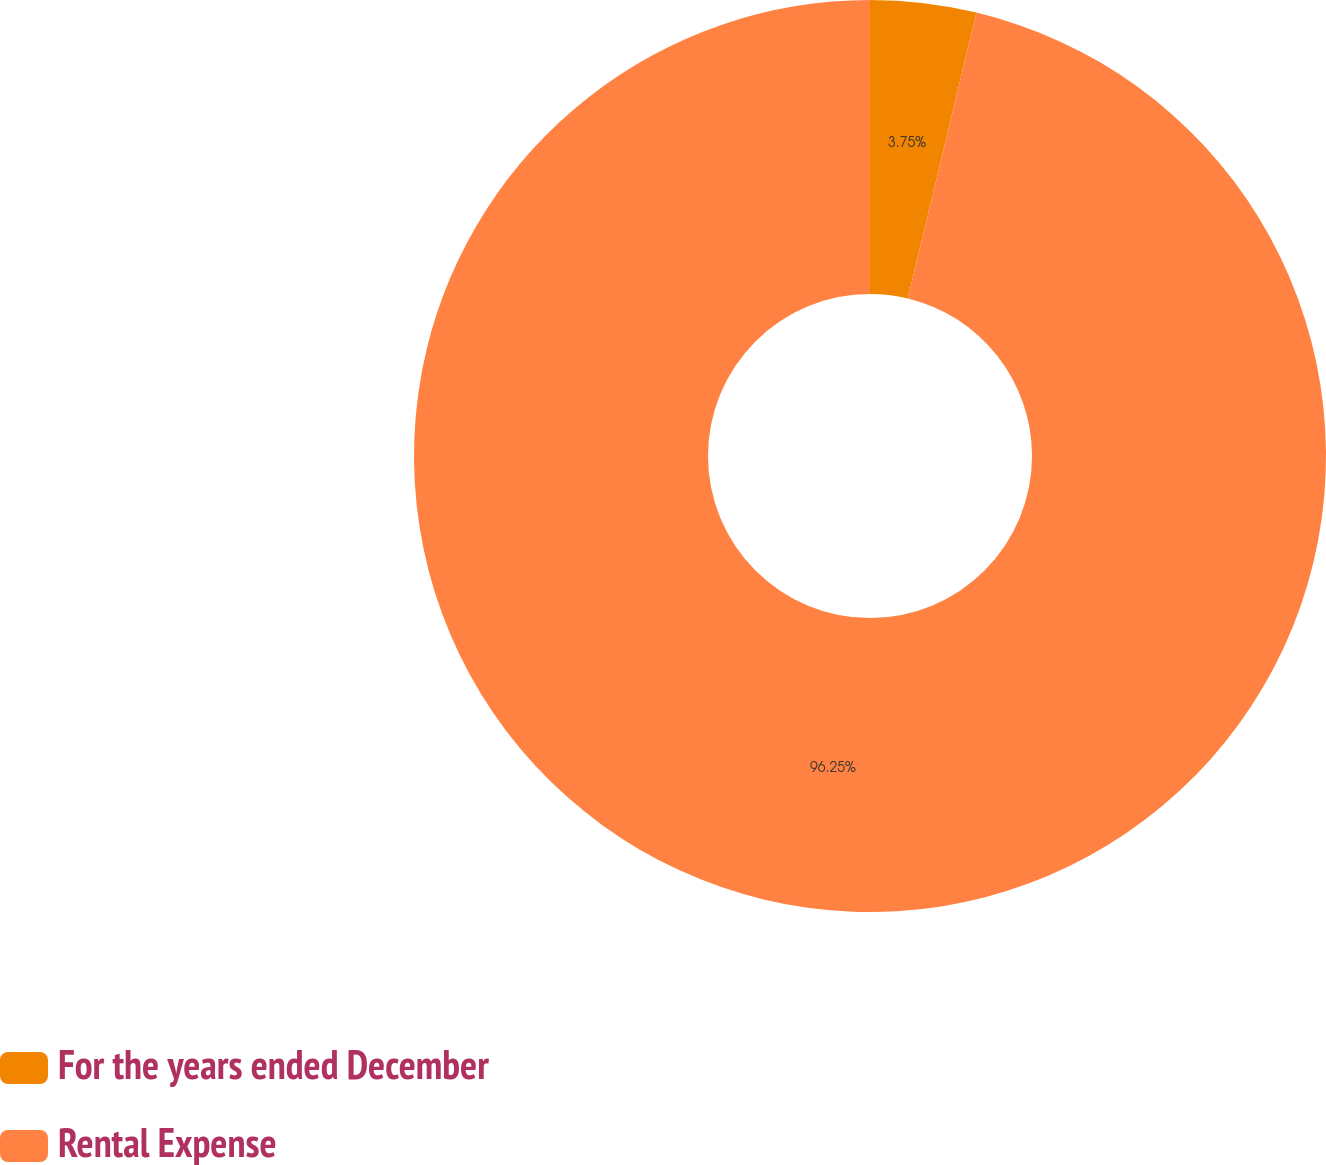Convert chart to OTSL. <chart><loc_0><loc_0><loc_500><loc_500><pie_chart><fcel>For the years ended December<fcel>Rental Expense<nl><fcel>3.75%<fcel>96.25%<nl></chart> 